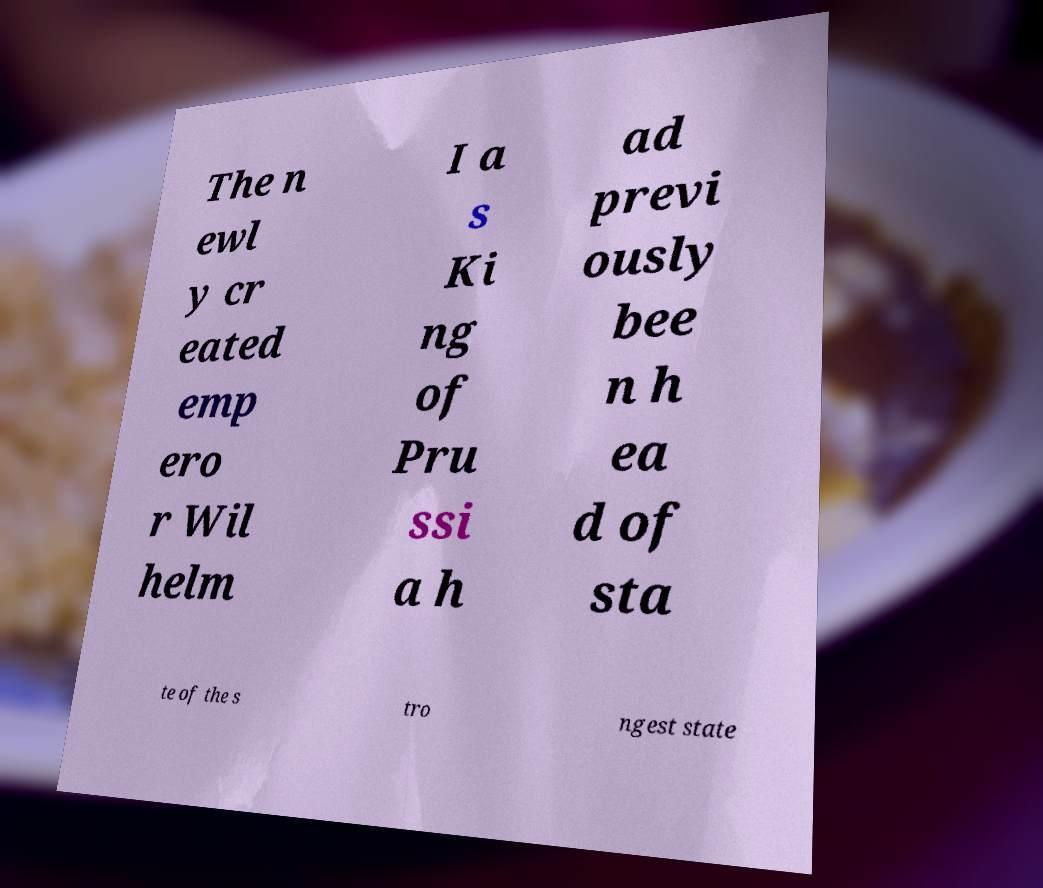I need the written content from this picture converted into text. Can you do that? The n ewl y cr eated emp ero r Wil helm I a s Ki ng of Pru ssi a h ad previ ously bee n h ea d of sta te of the s tro ngest state 